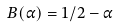<formula> <loc_0><loc_0><loc_500><loc_500>B ( \alpha ) = 1 / 2 - \alpha</formula> 